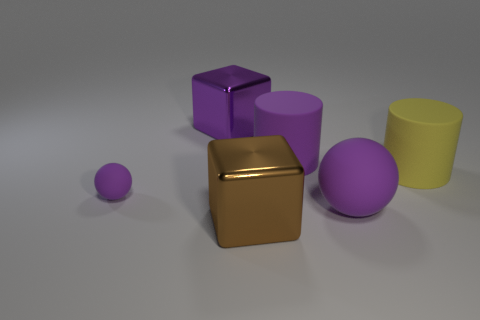Add 3 big yellow cylinders. How many objects exist? 9 Subtract all purple blocks. How many blocks are left? 1 Subtract 1 blocks. How many blocks are left? 1 Subtract all cylinders. How many objects are left? 4 Subtract all green balls. Subtract all yellow cylinders. How many balls are left? 2 Subtract all brown cubes. How many green cylinders are left? 0 Subtract all purple objects. Subtract all purple metal things. How many objects are left? 1 Add 1 tiny purple balls. How many tiny purple balls are left? 2 Add 1 big yellow objects. How many big yellow objects exist? 2 Subtract 0 gray spheres. How many objects are left? 6 